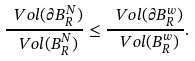<formula> <loc_0><loc_0><loc_500><loc_500>\frac { \ V o l ( \partial B ^ { N } _ { R } ) } { \ V o l ( B ^ { N } _ { R } ) } \leq \frac { \ V o l ( \partial B ^ { w } _ { R } ) } { \ V o l ( B ^ { w } _ { R } ) } .</formula> 